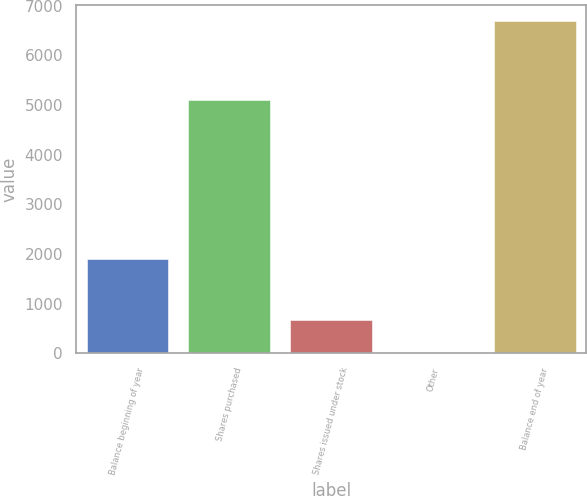Convert chart. <chart><loc_0><loc_0><loc_500><loc_500><bar_chart><fcel>Balance beginning of year<fcel>Shares purchased<fcel>Shares issued under stock<fcel>Other<fcel>Balance end of year<nl><fcel>1897<fcel>5104<fcel>678.4<fcel>11<fcel>6685<nl></chart> 